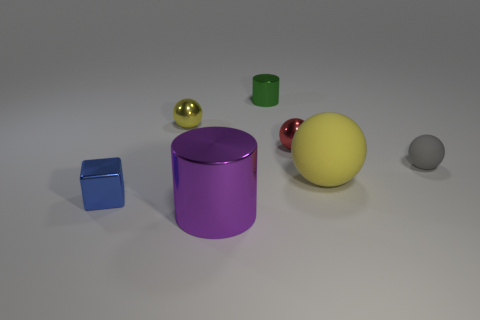There is a metal ball left of the big purple object; is its color the same as the large matte ball?
Your answer should be very brief. Yes. What size is the metallic cylinder that is behind the shiny block?
Offer a terse response. Small. Is there any other thing that is the same shape as the blue metallic object?
Your answer should be compact. No. Are there the same number of green metal cylinders that are in front of the gray rubber sphere and tiny green shiny cylinders?
Your answer should be compact. No. There is a green shiny cylinder; are there any green things left of it?
Offer a terse response. No. Do the yellow metal object and the large object on the right side of the small green shiny thing have the same shape?
Provide a short and direct response. Yes. What is the color of the cube that is the same material as the green cylinder?
Your answer should be very brief. Blue. What is the color of the tiny rubber object?
Your answer should be very brief. Gray. Do the small yellow sphere and the large thing in front of the big yellow rubber ball have the same material?
Keep it short and to the point. Yes. What number of tiny spheres are both in front of the red metallic sphere and to the left of the purple cylinder?
Your answer should be compact. 0. 